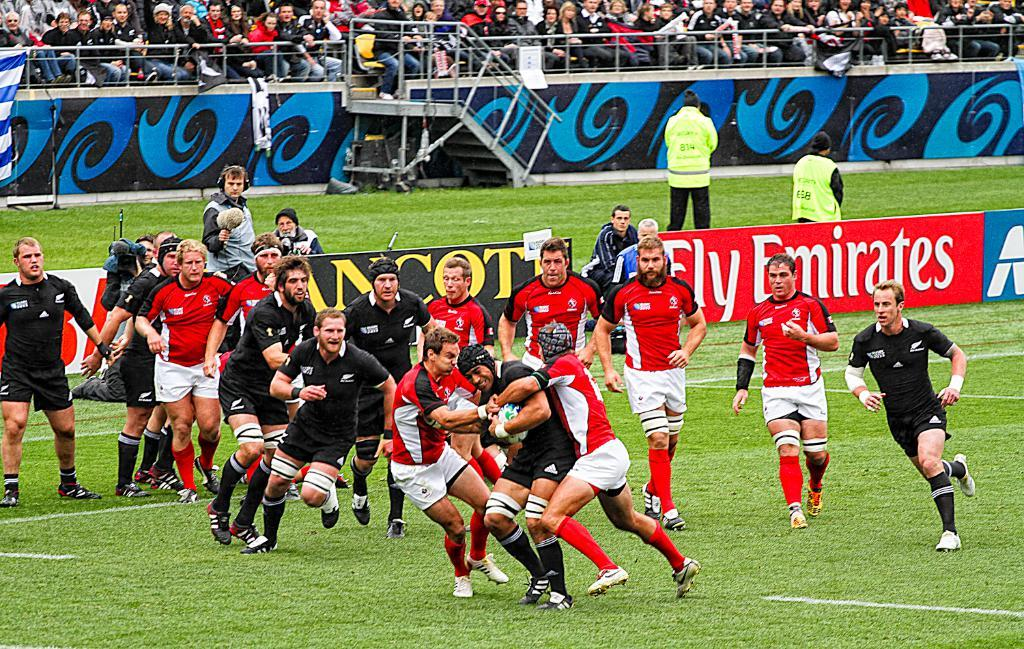Provide a one-sentence caption for the provided image. players going at it with a fly emirates ad in the back. 